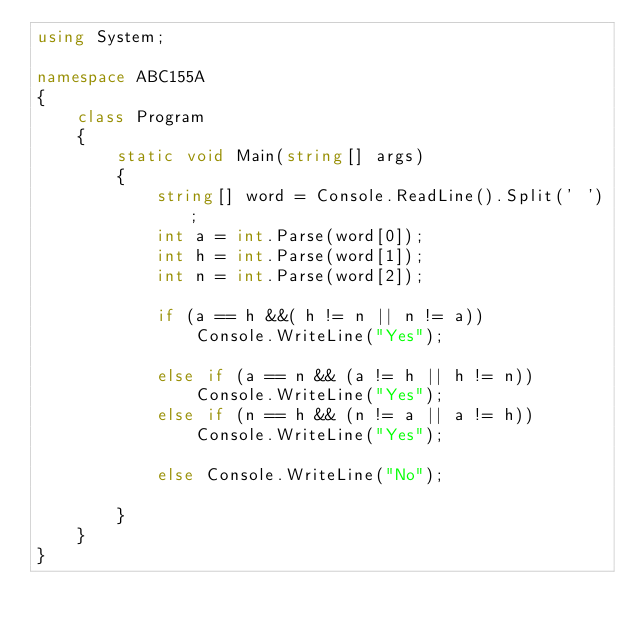<code> <loc_0><loc_0><loc_500><loc_500><_C#_>using System;

namespace ABC155A
{
    class Program
    {
        static void Main(string[] args)
        {
            string[] word = Console.ReadLine().Split(' ');
            int a = int.Parse(word[0]);
            int h = int.Parse(word[1]);
            int n = int.Parse(word[2]);

            if (a == h &&( h != n || n != a))
                Console.WriteLine("Yes"); 
           
            else if (a == n && (a != h || h != n))
                Console.WriteLine("Yes");
            else if (n == h && (n != a || a != h))
                Console.WriteLine("Yes");
           
            else Console.WriteLine("No");

        }
    }
}
</code> 